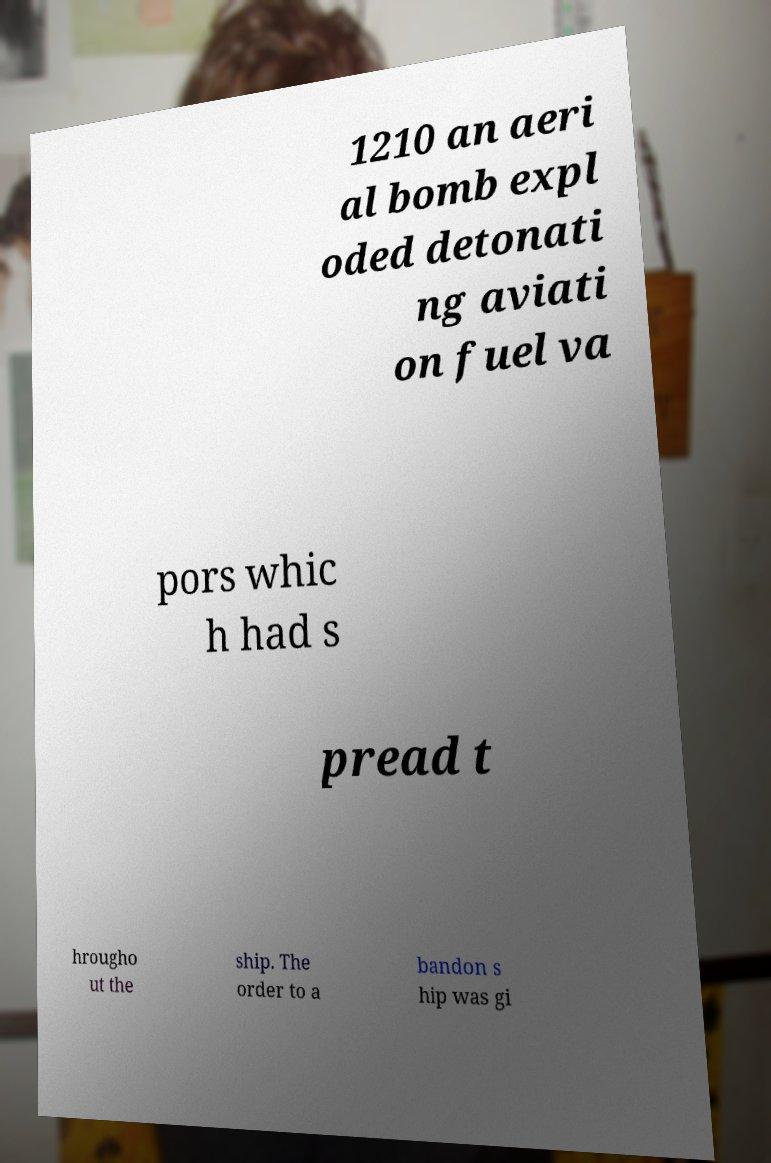There's text embedded in this image that I need extracted. Can you transcribe it verbatim? 1210 an aeri al bomb expl oded detonati ng aviati on fuel va pors whic h had s pread t hrougho ut the ship. The order to a bandon s hip was gi 